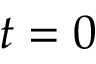<formula> <loc_0><loc_0><loc_500><loc_500>t = 0</formula> 